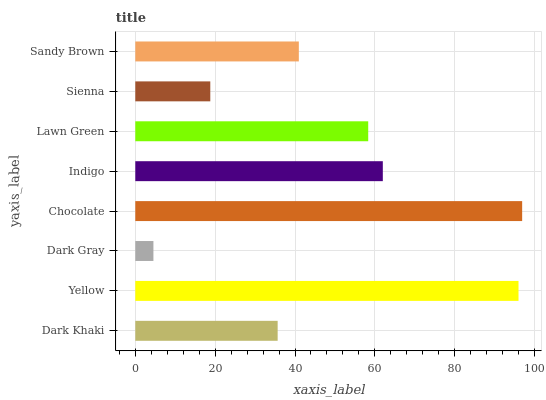Is Dark Gray the minimum?
Answer yes or no. Yes. Is Chocolate the maximum?
Answer yes or no. Yes. Is Yellow the minimum?
Answer yes or no. No. Is Yellow the maximum?
Answer yes or no. No. Is Yellow greater than Dark Khaki?
Answer yes or no. Yes. Is Dark Khaki less than Yellow?
Answer yes or no. Yes. Is Dark Khaki greater than Yellow?
Answer yes or no. No. Is Yellow less than Dark Khaki?
Answer yes or no. No. Is Lawn Green the high median?
Answer yes or no. Yes. Is Sandy Brown the low median?
Answer yes or no. Yes. Is Sandy Brown the high median?
Answer yes or no. No. Is Yellow the low median?
Answer yes or no. No. 